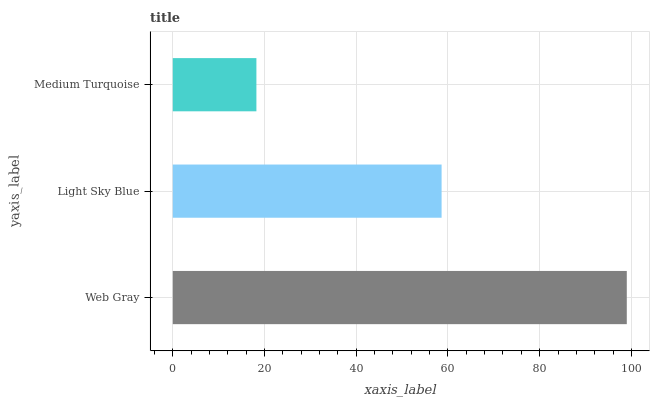Is Medium Turquoise the minimum?
Answer yes or no. Yes. Is Web Gray the maximum?
Answer yes or no. Yes. Is Light Sky Blue the minimum?
Answer yes or no. No. Is Light Sky Blue the maximum?
Answer yes or no. No. Is Web Gray greater than Light Sky Blue?
Answer yes or no. Yes. Is Light Sky Blue less than Web Gray?
Answer yes or no. Yes. Is Light Sky Blue greater than Web Gray?
Answer yes or no. No. Is Web Gray less than Light Sky Blue?
Answer yes or no. No. Is Light Sky Blue the high median?
Answer yes or no. Yes. Is Light Sky Blue the low median?
Answer yes or no. Yes. Is Medium Turquoise the high median?
Answer yes or no. No. Is Medium Turquoise the low median?
Answer yes or no. No. 